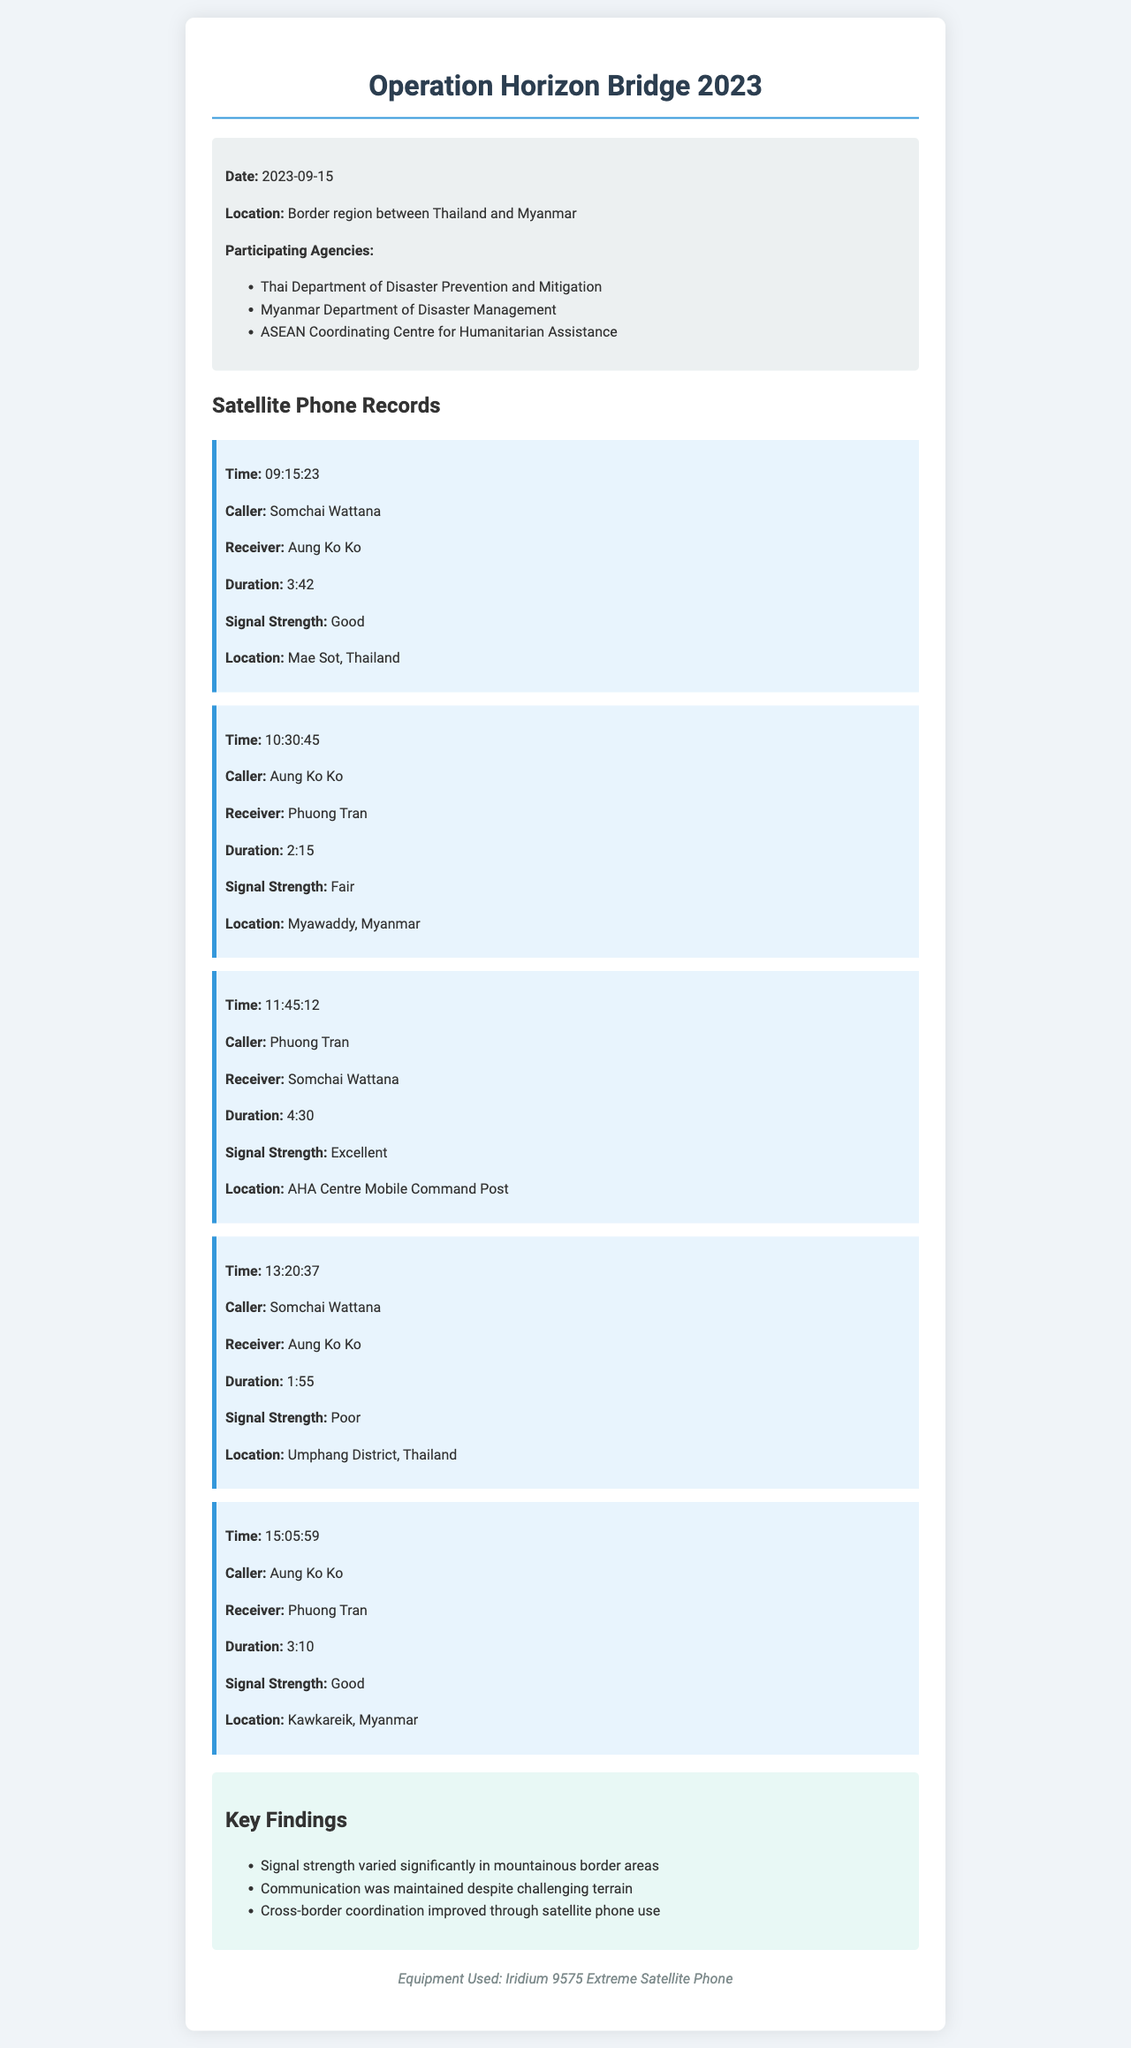What is the date of the exercise? The date of the exercise is stated in the exercise info section.
Answer: 2023-09-15 Who was the caller for the first record? The first record details the caller's name.
Answer: Somchai Wattana What was the signal strength during the call from Somchai Wattana to Aung Ko Ko at 13:20:37? The signal strength for the specified call is provided in the record.
Answer: Poor How long was the call between Aung Ko Ko and Phuong Tran at 10:30:45? The duration of the call is noted in the respective record.
Answer: 2:15 In which location did Phuong Tran make the call to Somchai Wattana at 11:45:12? The location of the caller during the call is referenced in the record.
Answer: AHA Centre Mobile Command Post Which communication method improved cross-border coordination? The key findings section indicates the method used for better coordination.
Answer: Satellite phone use What was the common impact on signal strength in mountainous areas? The key findings provide information about the signal strength issues.
Answer: Varied significantly How many records list a signal strength of 'Good'? By analyzing the records, the number of occurrences of 'Good' signal strength can be counted.
Answer: 3 What type of equipment was used during the exercise? The equipment used is detailed at the end of the document.
Answer: Iridium 9575 Extreme Satellite Phone 